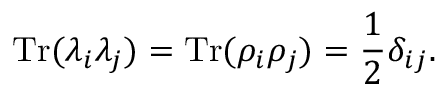<formula> <loc_0><loc_0><loc_500><loc_500>T r ( \lambda _ { i } \lambda _ { j } ) = T r ( \rho _ { i } \rho _ { j } ) = \frac { 1 } { 2 } \delta _ { i j } .</formula> 